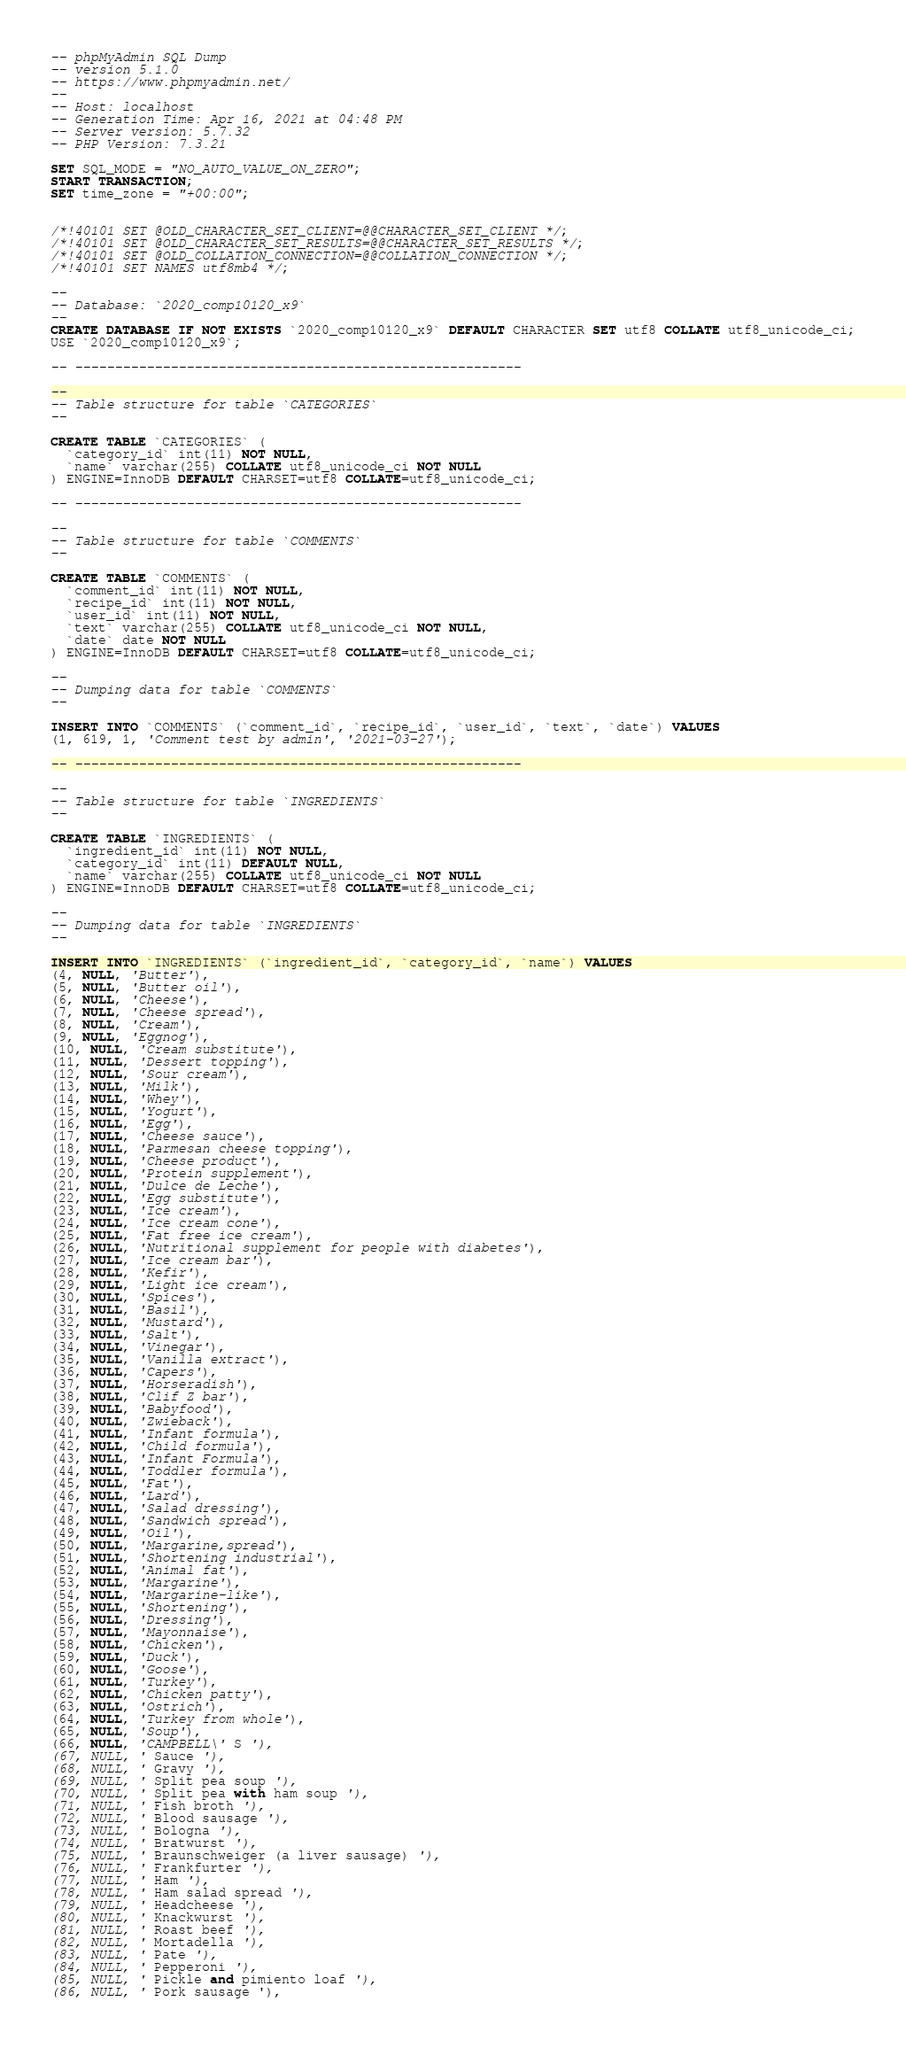<code> <loc_0><loc_0><loc_500><loc_500><_SQL_>-- phpMyAdmin SQL Dump
-- version 5.1.0
-- https://www.phpmyadmin.net/
--
-- Host: localhost
-- Generation Time: Apr 16, 2021 at 04:48 PM
-- Server version: 5.7.32
-- PHP Version: 7.3.21

SET SQL_MODE = "NO_AUTO_VALUE_ON_ZERO";
START TRANSACTION;
SET time_zone = "+00:00";


/*!40101 SET @OLD_CHARACTER_SET_CLIENT=@@CHARACTER_SET_CLIENT */;
/*!40101 SET @OLD_CHARACTER_SET_RESULTS=@@CHARACTER_SET_RESULTS */;
/*!40101 SET @OLD_COLLATION_CONNECTION=@@COLLATION_CONNECTION */;
/*!40101 SET NAMES utf8mb4 */;

--
-- Database: `2020_comp10120_x9`
--
CREATE DATABASE IF NOT EXISTS `2020_comp10120_x9` DEFAULT CHARACTER SET utf8 COLLATE utf8_unicode_ci;
USE `2020_comp10120_x9`;

-- --------------------------------------------------------

--
-- Table structure for table `CATEGORIES`
--

CREATE TABLE `CATEGORIES` (
  `category_id` int(11) NOT NULL,
  `name` varchar(255) COLLATE utf8_unicode_ci NOT NULL
) ENGINE=InnoDB DEFAULT CHARSET=utf8 COLLATE=utf8_unicode_ci;

-- --------------------------------------------------------

--
-- Table structure for table `COMMENTS`
--

CREATE TABLE `COMMENTS` (
  `comment_id` int(11) NOT NULL,
  `recipe_id` int(11) NOT NULL,
  `user_id` int(11) NOT NULL,
  `text` varchar(255) COLLATE utf8_unicode_ci NOT NULL,
  `date` date NOT NULL
) ENGINE=InnoDB DEFAULT CHARSET=utf8 COLLATE=utf8_unicode_ci;

--
-- Dumping data for table `COMMENTS`
--

INSERT INTO `COMMENTS` (`comment_id`, `recipe_id`, `user_id`, `text`, `date`) VALUES
(1, 619, 1, 'Comment test by admin', '2021-03-27');

-- --------------------------------------------------------

--
-- Table structure for table `INGREDIENTS`
--

CREATE TABLE `INGREDIENTS` (
  `ingredient_id` int(11) NOT NULL,
  `category_id` int(11) DEFAULT NULL,
  `name` varchar(255) COLLATE utf8_unicode_ci NOT NULL
) ENGINE=InnoDB DEFAULT CHARSET=utf8 COLLATE=utf8_unicode_ci;

--
-- Dumping data for table `INGREDIENTS`
--

INSERT INTO `INGREDIENTS` (`ingredient_id`, `category_id`, `name`) VALUES
(4, NULL, 'Butter'),
(5, NULL, 'Butter oil'),
(6, NULL, 'Cheese'),
(7, NULL, 'Cheese spread'),
(8, NULL, 'Cream'),
(9, NULL, 'Eggnog'),
(10, NULL, 'Cream substitute'),
(11, NULL, 'Dessert topping'),
(12, NULL, 'Sour cream'),
(13, NULL, 'Milk'),
(14, NULL, 'Whey'),
(15, NULL, 'Yogurt'),
(16, NULL, 'Egg'),
(17, NULL, 'Cheese sauce'),
(18, NULL, 'Parmesan cheese topping'),
(19, NULL, 'Cheese product'),
(20, NULL, 'Protein supplement'),
(21, NULL, 'Dulce de Leche'),
(22, NULL, 'Egg substitute'),
(23, NULL, 'Ice cream'),
(24, NULL, 'Ice cream cone'),
(25, NULL, 'Fat free ice cream'),
(26, NULL, 'Nutritional supplement for people with diabetes'),
(27, NULL, 'Ice cream bar'),
(28, NULL, 'Kefir'),
(29, NULL, 'Light ice cream'),
(30, NULL, 'Spices'),
(31, NULL, 'Basil'),
(32, NULL, 'Mustard'),
(33, NULL, 'Salt'),
(34, NULL, 'Vinegar'),
(35, NULL, 'Vanilla extract'),
(36, NULL, 'Capers'),
(37, NULL, 'Horseradish'),
(38, NULL, 'Clif Z bar'),
(39, NULL, 'Babyfood'),
(40, NULL, 'Zwieback'),
(41, NULL, 'Infant formula'),
(42, NULL, 'Child formula'),
(43, NULL, 'Infant Formula'),
(44, NULL, 'Toddler formula'),
(45, NULL, 'Fat'),
(46, NULL, 'Lard'),
(47, NULL, 'Salad dressing'),
(48, NULL, 'Sandwich spread'),
(49, NULL, 'Oil'),
(50, NULL, 'Margarine,spread'),
(51, NULL, 'Shortening industrial'),
(52, NULL, 'Animal fat'),
(53, NULL, 'Margarine'),
(54, NULL, 'Margarine-like'),
(55, NULL, 'Shortening'),
(56, NULL, 'Dressing'),
(57, NULL, 'Mayonnaise'),
(58, NULL, 'Chicken'),
(59, NULL, 'Duck'),
(60, NULL, 'Goose'),
(61, NULL, 'Turkey'),
(62, NULL, 'Chicken patty'),
(63, NULL, 'Ostrich'),
(64, NULL, 'Turkey from whole'),
(65, NULL, 'Soup'),
(66, NULL, 'CAMPBELL\' S '),
(67, NULL, ' Sauce '),
(68, NULL, ' Gravy '),
(69, NULL, ' Split pea soup '),
(70, NULL, ' Split pea with ham soup '),
(71, NULL, ' Fish broth '),
(72, NULL, ' Blood sausage '),
(73, NULL, ' Bologna '),
(74, NULL, ' Bratwurst '),
(75, NULL, ' Braunschweiger (a liver sausage) '),
(76, NULL, ' Frankfurter '),
(77, NULL, ' Ham '),
(78, NULL, ' Ham salad spread '),
(79, NULL, ' Headcheese '),
(80, NULL, ' Knackwurst '),
(81, NULL, ' Roast beef '),
(82, NULL, ' Mortadella '),
(83, NULL, ' Pate '),
(84, NULL, ' Pepperoni '),
(85, NULL, ' Pickle and pimiento loaf '),
(86, NULL, ' Pork sausage '),</code> 